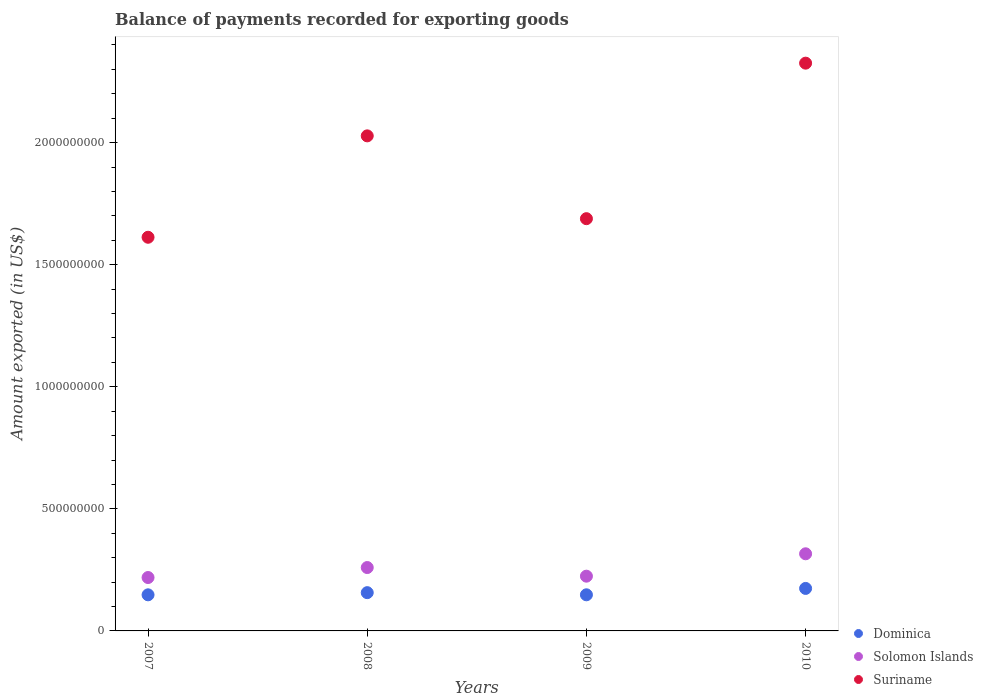How many different coloured dotlines are there?
Make the answer very short. 3. Is the number of dotlines equal to the number of legend labels?
Your answer should be very brief. Yes. What is the amount exported in Suriname in 2008?
Offer a very short reply. 2.03e+09. Across all years, what is the maximum amount exported in Suriname?
Your answer should be very brief. 2.33e+09. Across all years, what is the minimum amount exported in Suriname?
Make the answer very short. 1.61e+09. In which year was the amount exported in Dominica minimum?
Ensure brevity in your answer.  2007. What is the total amount exported in Suriname in the graph?
Make the answer very short. 7.65e+09. What is the difference between the amount exported in Solomon Islands in 2009 and that in 2010?
Your answer should be very brief. -9.17e+07. What is the difference between the amount exported in Suriname in 2010 and the amount exported in Dominica in 2008?
Keep it short and to the point. 2.17e+09. What is the average amount exported in Solomon Islands per year?
Make the answer very short. 2.55e+08. In the year 2007, what is the difference between the amount exported in Solomon Islands and amount exported in Dominica?
Provide a succinct answer. 7.08e+07. In how many years, is the amount exported in Solomon Islands greater than 2300000000 US$?
Keep it short and to the point. 0. What is the ratio of the amount exported in Solomon Islands in 2009 to that in 2010?
Your answer should be compact. 0.71. Is the amount exported in Solomon Islands in 2007 less than that in 2010?
Make the answer very short. Yes. What is the difference between the highest and the second highest amount exported in Suriname?
Give a very brief answer. 2.98e+08. What is the difference between the highest and the lowest amount exported in Solomon Islands?
Make the answer very short. 9.72e+07. Is it the case that in every year, the sum of the amount exported in Suriname and amount exported in Solomon Islands  is greater than the amount exported in Dominica?
Your answer should be compact. Yes. Is the amount exported in Suriname strictly greater than the amount exported in Dominica over the years?
Make the answer very short. Yes. Is the amount exported in Suriname strictly less than the amount exported in Dominica over the years?
Provide a succinct answer. No. How many dotlines are there?
Your answer should be very brief. 3. Does the graph contain any zero values?
Offer a very short reply. No. Where does the legend appear in the graph?
Keep it short and to the point. Bottom right. How many legend labels are there?
Ensure brevity in your answer.  3. How are the legend labels stacked?
Give a very brief answer. Vertical. What is the title of the graph?
Your answer should be very brief. Balance of payments recorded for exporting goods. Does "East Asia (all income levels)" appear as one of the legend labels in the graph?
Ensure brevity in your answer.  No. What is the label or title of the X-axis?
Make the answer very short. Years. What is the label or title of the Y-axis?
Keep it short and to the point. Amount exported (in US$). What is the Amount exported (in US$) of Dominica in 2007?
Give a very brief answer. 1.48e+08. What is the Amount exported (in US$) in Solomon Islands in 2007?
Keep it short and to the point. 2.19e+08. What is the Amount exported (in US$) in Suriname in 2007?
Make the answer very short. 1.61e+09. What is the Amount exported (in US$) in Dominica in 2008?
Give a very brief answer. 1.57e+08. What is the Amount exported (in US$) in Solomon Islands in 2008?
Make the answer very short. 2.60e+08. What is the Amount exported (in US$) of Suriname in 2008?
Offer a terse response. 2.03e+09. What is the Amount exported (in US$) in Dominica in 2009?
Your answer should be very brief. 1.48e+08. What is the Amount exported (in US$) of Solomon Islands in 2009?
Offer a terse response. 2.24e+08. What is the Amount exported (in US$) in Suriname in 2009?
Your answer should be compact. 1.69e+09. What is the Amount exported (in US$) of Dominica in 2010?
Provide a succinct answer. 1.74e+08. What is the Amount exported (in US$) of Solomon Islands in 2010?
Your response must be concise. 3.16e+08. What is the Amount exported (in US$) of Suriname in 2010?
Provide a succinct answer. 2.33e+09. Across all years, what is the maximum Amount exported (in US$) in Dominica?
Offer a very short reply. 1.74e+08. Across all years, what is the maximum Amount exported (in US$) in Solomon Islands?
Offer a terse response. 3.16e+08. Across all years, what is the maximum Amount exported (in US$) of Suriname?
Provide a succinct answer. 2.33e+09. Across all years, what is the minimum Amount exported (in US$) of Dominica?
Give a very brief answer. 1.48e+08. Across all years, what is the minimum Amount exported (in US$) of Solomon Islands?
Keep it short and to the point. 2.19e+08. Across all years, what is the minimum Amount exported (in US$) of Suriname?
Make the answer very short. 1.61e+09. What is the total Amount exported (in US$) in Dominica in the graph?
Provide a short and direct response. 6.27e+08. What is the total Amount exported (in US$) of Solomon Islands in the graph?
Offer a terse response. 1.02e+09. What is the total Amount exported (in US$) of Suriname in the graph?
Ensure brevity in your answer.  7.65e+09. What is the difference between the Amount exported (in US$) in Dominica in 2007 and that in 2008?
Offer a very short reply. -8.89e+06. What is the difference between the Amount exported (in US$) in Solomon Islands in 2007 and that in 2008?
Make the answer very short. -4.09e+07. What is the difference between the Amount exported (in US$) in Suriname in 2007 and that in 2008?
Your answer should be compact. -4.15e+08. What is the difference between the Amount exported (in US$) of Dominica in 2007 and that in 2009?
Keep it short and to the point. -1.05e+05. What is the difference between the Amount exported (in US$) in Solomon Islands in 2007 and that in 2009?
Ensure brevity in your answer.  -5.54e+06. What is the difference between the Amount exported (in US$) in Suriname in 2007 and that in 2009?
Provide a short and direct response. -7.61e+07. What is the difference between the Amount exported (in US$) in Dominica in 2007 and that in 2010?
Keep it short and to the point. -2.62e+07. What is the difference between the Amount exported (in US$) of Solomon Islands in 2007 and that in 2010?
Offer a terse response. -9.72e+07. What is the difference between the Amount exported (in US$) of Suriname in 2007 and that in 2010?
Keep it short and to the point. -7.13e+08. What is the difference between the Amount exported (in US$) in Dominica in 2008 and that in 2009?
Your response must be concise. 8.78e+06. What is the difference between the Amount exported (in US$) of Solomon Islands in 2008 and that in 2009?
Make the answer very short. 3.54e+07. What is the difference between the Amount exported (in US$) in Suriname in 2008 and that in 2009?
Make the answer very short. 3.39e+08. What is the difference between the Amount exported (in US$) of Dominica in 2008 and that in 2010?
Offer a very short reply. -1.73e+07. What is the difference between the Amount exported (in US$) in Solomon Islands in 2008 and that in 2010?
Your answer should be compact. -5.63e+07. What is the difference between the Amount exported (in US$) in Suriname in 2008 and that in 2010?
Give a very brief answer. -2.98e+08. What is the difference between the Amount exported (in US$) in Dominica in 2009 and that in 2010?
Give a very brief answer. -2.61e+07. What is the difference between the Amount exported (in US$) in Solomon Islands in 2009 and that in 2010?
Make the answer very short. -9.17e+07. What is the difference between the Amount exported (in US$) of Suriname in 2009 and that in 2010?
Provide a succinct answer. -6.37e+08. What is the difference between the Amount exported (in US$) in Dominica in 2007 and the Amount exported (in US$) in Solomon Islands in 2008?
Make the answer very short. -1.12e+08. What is the difference between the Amount exported (in US$) of Dominica in 2007 and the Amount exported (in US$) of Suriname in 2008?
Offer a terse response. -1.88e+09. What is the difference between the Amount exported (in US$) in Solomon Islands in 2007 and the Amount exported (in US$) in Suriname in 2008?
Give a very brief answer. -1.81e+09. What is the difference between the Amount exported (in US$) of Dominica in 2007 and the Amount exported (in US$) of Solomon Islands in 2009?
Provide a short and direct response. -7.64e+07. What is the difference between the Amount exported (in US$) of Dominica in 2007 and the Amount exported (in US$) of Suriname in 2009?
Offer a terse response. -1.54e+09. What is the difference between the Amount exported (in US$) of Solomon Islands in 2007 and the Amount exported (in US$) of Suriname in 2009?
Your answer should be very brief. -1.47e+09. What is the difference between the Amount exported (in US$) in Dominica in 2007 and the Amount exported (in US$) in Solomon Islands in 2010?
Ensure brevity in your answer.  -1.68e+08. What is the difference between the Amount exported (in US$) in Dominica in 2007 and the Amount exported (in US$) in Suriname in 2010?
Give a very brief answer. -2.18e+09. What is the difference between the Amount exported (in US$) of Solomon Islands in 2007 and the Amount exported (in US$) of Suriname in 2010?
Make the answer very short. -2.11e+09. What is the difference between the Amount exported (in US$) of Dominica in 2008 and the Amount exported (in US$) of Solomon Islands in 2009?
Your answer should be very brief. -6.75e+07. What is the difference between the Amount exported (in US$) in Dominica in 2008 and the Amount exported (in US$) in Suriname in 2009?
Provide a short and direct response. -1.53e+09. What is the difference between the Amount exported (in US$) in Solomon Islands in 2008 and the Amount exported (in US$) in Suriname in 2009?
Your answer should be compact. -1.43e+09. What is the difference between the Amount exported (in US$) in Dominica in 2008 and the Amount exported (in US$) in Solomon Islands in 2010?
Make the answer very short. -1.59e+08. What is the difference between the Amount exported (in US$) in Dominica in 2008 and the Amount exported (in US$) in Suriname in 2010?
Your answer should be compact. -2.17e+09. What is the difference between the Amount exported (in US$) of Solomon Islands in 2008 and the Amount exported (in US$) of Suriname in 2010?
Provide a short and direct response. -2.07e+09. What is the difference between the Amount exported (in US$) of Dominica in 2009 and the Amount exported (in US$) of Solomon Islands in 2010?
Your response must be concise. -1.68e+08. What is the difference between the Amount exported (in US$) of Dominica in 2009 and the Amount exported (in US$) of Suriname in 2010?
Give a very brief answer. -2.18e+09. What is the difference between the Amount exported (in US$) in Solomon Islands in 2009 and the Amount exported (in US$) in Suriname in 2010?
Ensure brevity in your answer.  -2.10e+09. What is the average Amount exported (in US$) in Dominica per year?
Your answer should be very brief. 1.57e+08. What is the average Amount exported (in US$) in Solomon Islands per year?
Keep it short and to the point. 2.55e+08. What is the average Amount exported (in US$) of Suriname per year?
Offer a terse response. 1.91e+09. In the year 2007, what is the difference between the Amount exported (in US$) of Dominica and Amount exported (in US$) of Solomon Islands?
Your answer should be very brief. -7.08e+07. In the year 2007, what is the difference between the Amount exported (in US$) of Dominica and Amount exported (in US$) of Suriname?
Provide a succinct answer. -1.46e+09. In the year 2007, what is the difference between the Amount exported (in US$) in Solomon Islands and Amount exported (in US$) in Suriname?
Offer a very short reply. -1.39e+09. In the year 2008, what is the difference between the Amount exported (in US$) of Dominica and Amount exported (in US$) of Solomon Islands?
Offer a terse response. -1.03e+08. In the year 2008, what is the difference between the Amount exported (in US$) of Dominica and Amount exported (in US$) of Suriname?
Provide a short and direct response. -1.87e+09. In the year 2008, what is the difference between the Amount exported (in US$) in Solomon Islands and Amount exported (in US$) in Suriname?
Your response must be concise. -1.77e+09. In the year 2009, what is the difference between the Amount exported (in US$) of Dominica and Amount exported (in US$) of Solomon Islands?
Your answer should be compact. -7.63e+07. In the year 2009, what is the difference between the Amount exported (in US$) in Dominica and Amount exported (in US$) in Suriname?
Keep it short and to the point. -1.54e+09. In the year 2009, what is the difference between the Amount exported (in US$) of Solomon Islands and Amount exported (in US$) of Suriname?
Give a very brief answer. -1.46e+09. In the year 2010, what is the difference between the Amount exported (in US$) in Dominica and Amount exported (in US$) in Solomon Islands?
Provide a succinct answer. -1.42e+08. In the year 2010, what is the difference between the Amount exported (in US$) of Dominica and Amount exported (in US$) of Suriname?
Make the answer very short. -2.15e+09. In the year 2010, what is the difference between the Amount exported (in US$) of Solomon Islands and Amount exported (in US$) of Suriname?
Keep it short and to the point. -2.01e+09. What is the ratio of the Amount exported (in US$) of Dominica in 2007 to that in 2008?
Your answer should be compact. 0.94. What is the ratio of the Amount exported (in US$) of Solomon Islands in 2007 to that in 2008?
Offer a terse response. 0.84. What is the ratio of the Amount exported (in US$) of Suriname in 2007 to that in 2008?
Keep it short and to the point. 0.8. What is the ratio of the Amount exported (in US$) in Dominica in 2007 to that in 2009?
Your answer should be compact. 1. What is the ratio of the Amount exported (in US$) in Solomon Islands in 2007 to that in 2009?
Offer a terse response. 0.98. What is the ratio of the Amount exported (in US$) of Suriname in 2007 to that in 2009?
Make the answer very short. 0.95. What is the ratio of the Amount exported (in US$) of Dominica in 2007 to that in 2010?
Keep it short and to the point. 0.85. What is the ratio of the Amount exported (in US$) in Solomon Islands in 2007 to that in 2010?
Your response must be concise. 0.69. What is the ratio of the Amount exported (in US$) in Suriname in 2007 to that in 2010?
Provide a short and direct response. 0.69. What is the ratio of the Amount exported (in US$) of Dominica in 2008 to that in 2009?
Provide a succinct answer. 1.06. What is the ratio of the Amount exported (in US$) in Solomon Islands in 2008 to that in 2009?
Offer a very short reply. 1.16. What is the ratio of the Amount exported (in US$) of Suriname in 2008 to that in 2009?
Offer a very short reply. 1.2. What is the ratio of the Amount exported (in US$) of Dominica in 2008 to that in 2010?
Keep it short and to the point. 0.9. What is the ratio of the Amount exported (in US$) of Solomon Islands in 2008 to that in 2010?
Offer a terse response. 0.82. What is the ratio of the Amount exported (in US$) in Suriname in 2008 to that in 2010?
Provide a short and direct response. 0.87. What is the ratio of the Amount exported (in US$) in Dominica in 2009 to that in 2010?
Your response must be concise. 0.85. What is the ratio of the Amount exported (in US$) of Solomon Islands in 2009 to that in 2010?
Provide a succinct answer. 0.71. What is the ratio of the Amount exported (in US$) in Suriname in 2009 to that in 2010?
Provide a short and direct response. 0.73. What is the difference between the highest and the second highest Amount exported (in US$) in Dominica?
Offer a terse response. 1.73e+07. What is the difference between the highest and the second highest Amount exported (in US$) of Solomon Islands?
Your answer should be compact. 5.63e+07. What is the difference between the highest and the second highest Amount exported (in US$) in Suriname?
Make the answer very short. 2.98e+08. What is the difference between the highest and the lowest Amount exported (in US$) of Dominica?
Make the answer very short. 2.62e+07. What is the difference between the highest and the lowest Amount exported (in US$) of Solomon Islands?
Make the answer very short. 9.72e+07. What is the difference between the highest and the lowest Amount exported (in US$) of Suriname?
Ensure brevity in your answer.  7.13e+08. 